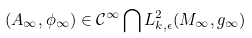<formula> <loc_0><loc_0><loc_500><loc_500>( A _ { \infty } , \phi _ { \infty } ) \in \mathcal { C } ^ { \infty } \bigcap L ^ { 2 } _ { k , \epsilon } ( M _ { \infty } , g _ { \infty } )</formula> 